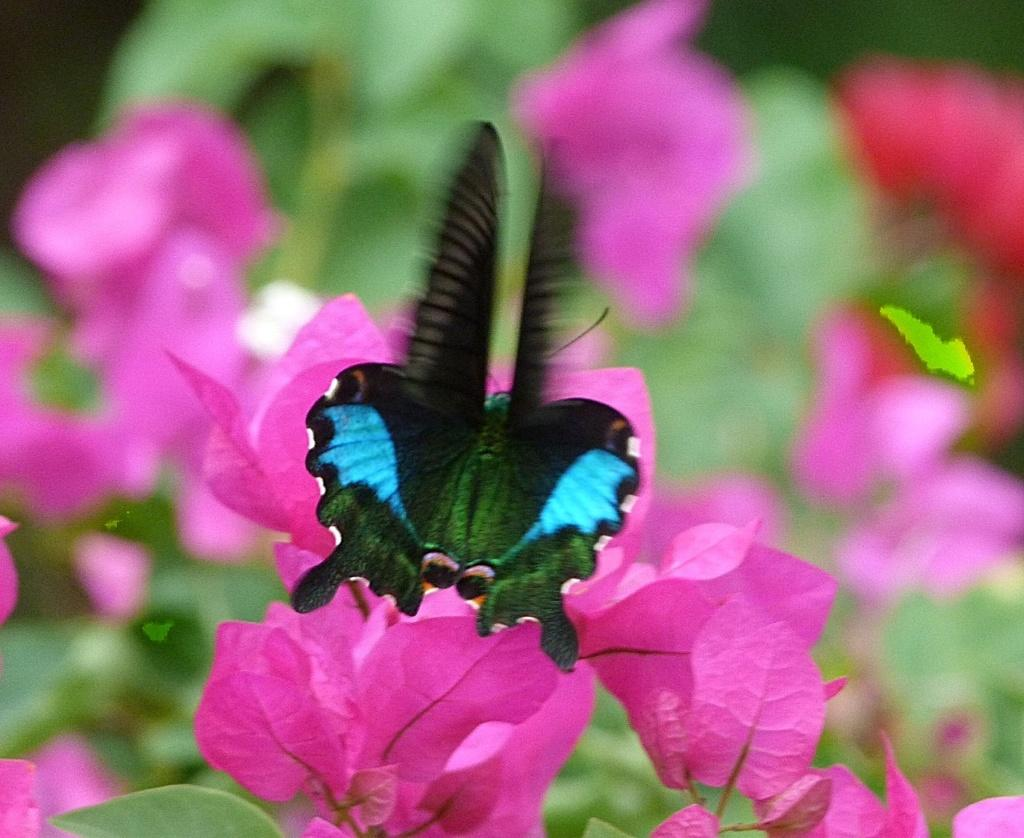What is the main subject of the picture? The main subject of the picture is a butterfly. Can you describe the colors of the butterfly? The butterfly has blue and green colors. What type of flowers can be seen in the picture? There are pink color flowers in the picture. How would you describe the background of the image? The background of the image is blurred. What type of noise can be heard coming from the mailbox in the image? There is no mailbox present in the image, so it's not possible to determine what, if any, noise might be heard. 